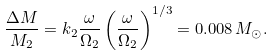<formula> <loc_0><loc_0><loc_500><loc_500>\frac { \Delta M } { M _ { 2 } } = k _ { 2 } \frac { \omega } { \Omega _ { 2 } } \left ( \frac { \omega } { \Omega _ { 2 } } \right ) ^ { 1 / 3 } = 0 . 0 0 8 \, M _ { \odot } .</formula> 